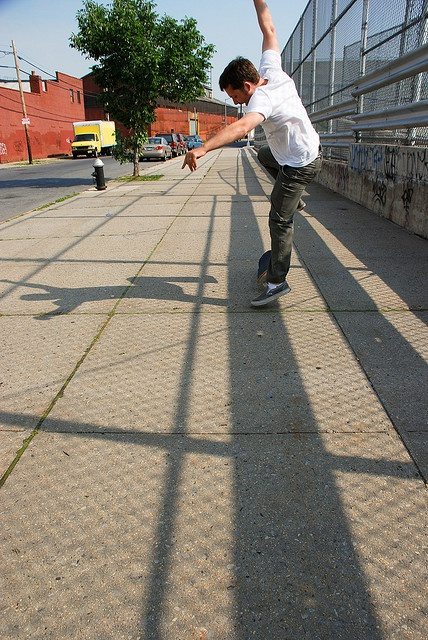Describe the objects in this image and their specific colors. I can see people in gray, black, white, and darkgray tones, truck in gray, black, khaki, and lightgray tones, car in gray, khaki, black, and lightgray tones, skateboard in gray, black, darkgreen, and darkblue tones, and car in gray, darkgray, and black tones in this image. 